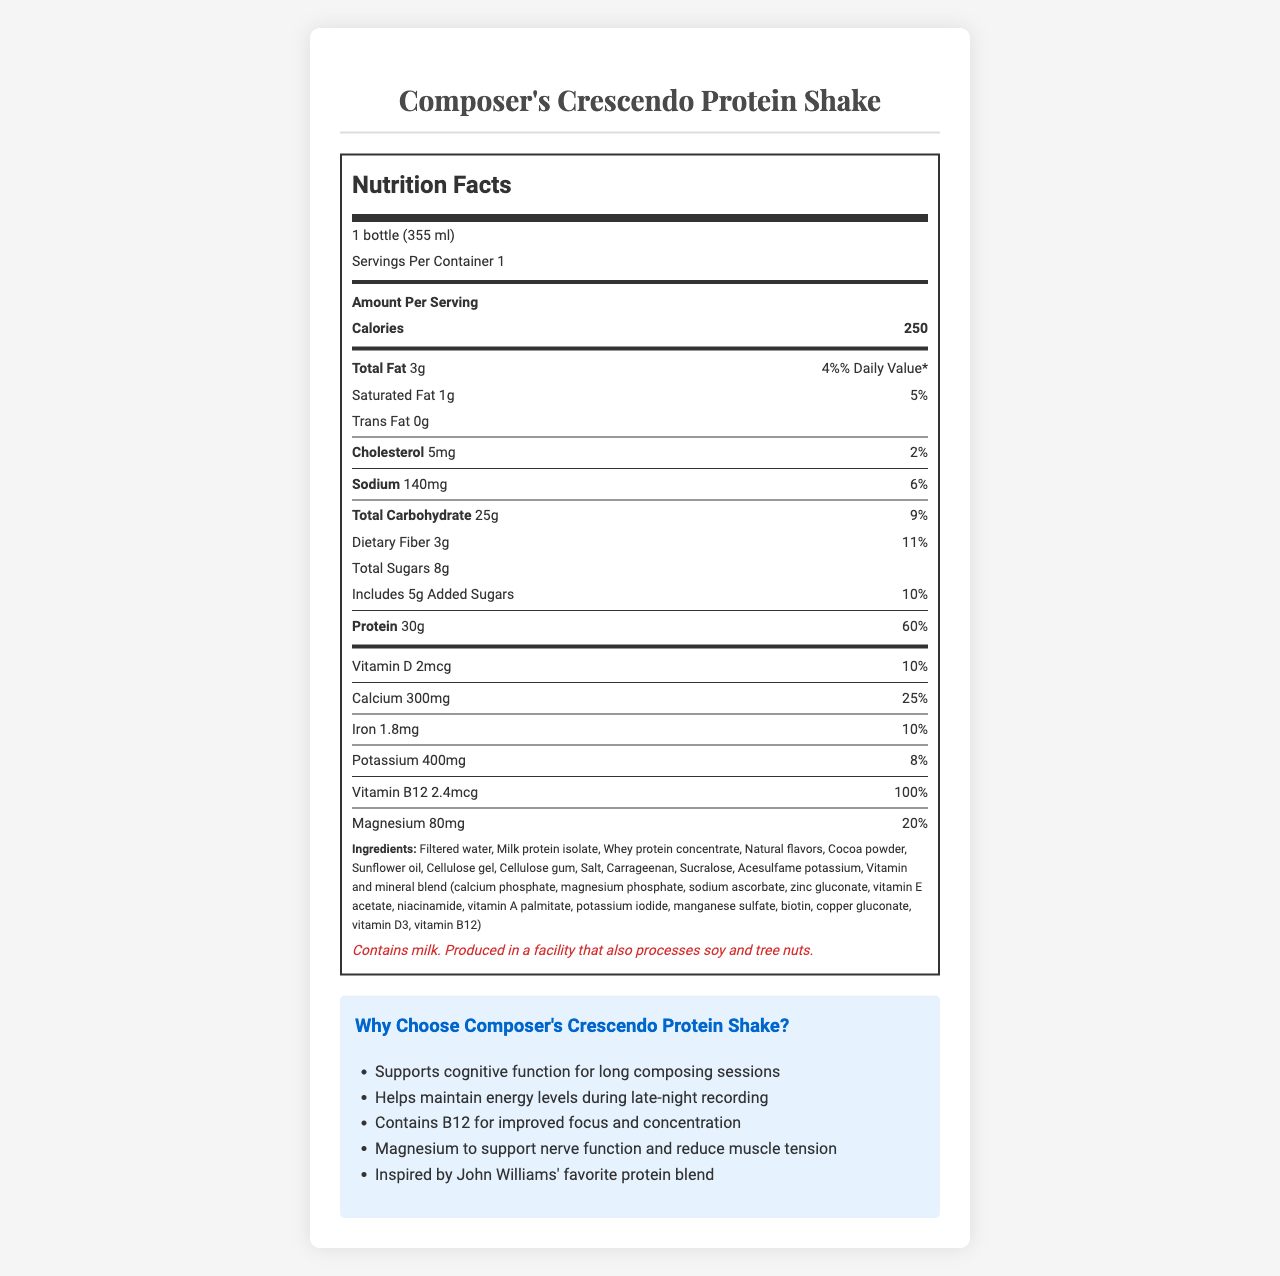what is the serving size for Composer's Crescendo Protein Shake? The serving size information is located at the top of the Nutrition Facts section.
Answer: 1 bottle (355 ml) how many calories are there per serving? The calories per serving are listed under the "Amount Per Serving" heading.
Answer: 250 how much protein does this shake provide? The protein content is stated in the Nutrition Facts under the "Protein" section.
Answer: 30g how much calcium is present per serving? The calcium content can be found in the Nutrition Facts under the "Calcium" section.
Answer: 300mg what is the percentage Daily Value for vitamin D? The percentage Daily Value for vitamin D is given in the Nutrition Facts section.
Answer: 10% what flavor is Composer's Crescendo Protein Shake? The flavor is mentioned at the end of the document content provided.
Answer: Rich Chocolate Symphony how many grams of dietary fiber are included in one serving? The dietary fiber amount is mentioned in the "Total Carbohydrate" section of Nutrition Facts.
Answer: 3g what is the total fat content? The total fat content is mentioned under the "Total Fat" section.
Answer: 3g which ingredient is listed first in the ingredients section? A. Milk protein isolate B. Cocoa Powder C. Filtered water D. Sunflower oil Filtered water is listed first in the ingredients section.
Answer: C which components are part of the vitamin and mineral blend? I. Calcium phosphate II. Potassium iodide III. Vitamin E acetate IV. Sodium ascorbate The ingredients list includes all these components as part of the vitamin and mineral blend.
Answer: I, II, III, IV does the product contain any allergens? The allergen information states that it contains milk and is produced in a facility that also processes soy and tree nuts.
Answer: Yes describe the main purpose of Composer's Crescendo Protein Shake based on the document. The summary includes key marketing claims like support for long composing sessions, energy maintenance, and added vitamins and minerals for focus and nerve function, mentioned in the "Why Choose Composer's Crescendo Protein Shake?" section.
Answer: Composer's Crescendo Protein Shake is designed to support cognitive function for long composing sessions, maintain energy levels during late-night recording, and improve focus and concentration with added vitamins and minerals. is this product suitable for someone with a tree nut allergy? The product is produced in a facility that processes tree nuts, making it unsuitable for those with a tree nut allergy.
Answer: No what inspired the Composer's Crescendo Protein Shake blend? The inspiration for the blend is mentioned in the marketing claims section as being inspired by John Williams' favorite protein blend.
Answer: John Williams' favorite protein blend how much cholesterol does the shake contain? The cholesterol amount is provided in the "Cholesterol" section of the Nutrition Facts.
Answer: 5mg how much added sugar is there in one serving? The added sugars amount is listed under the "Total Sugars" section in Nutrition Facts.
Answer: 5g what does this shake claim to help with during recording sessions? The claim is found in the marketing claims section.
Answer: Helps maintain energy levels during late-night recording what amount of magnesium does the product offer? The amount of magnesium is listed in the Nutrition Facts section.
Answer: 80mg I have a soy allergy. Is this shake safe for me to consume? The product is produced in a facility that also processes soy, but it is not stated whether soy is present in the product itself.
Answer: Not enough information how can Composer's Crescendo Protein Shake help with focus and concentration? The marketing claims mention that the shake contains B12, which is beneficial for focus and concentration.
Answer: Contains B12 for improved focus and concentration how much sodium does one bottle contain? The sodium content per serving is listed in the Nutrition Facts section.
Answer: 140mg 